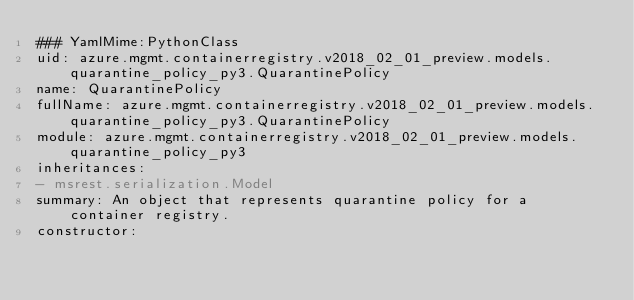<code> <loc_0><loc_0><loc_500><loc_500><_YAML_>### YamlMime:PythonClass
uid: azure.mgmt.containerregistry.v2018_02_01_preview.models.quarantine_policy_py3.QuarantinePolicy
name: QuarantinePolicy
fullName: azure.mgmt.containerregistry.v2018_02_01_preview.models.quarantine_policy_py3.QuarantinePolicy
module: azure.mgmt.containerregistry.v2018_02_01_preview.models.quarantine_policy_py3
inheritances:
- msrest.serialization.Model
summary: An object that represents quarantine policy for a container registry.
constructor:</code> 